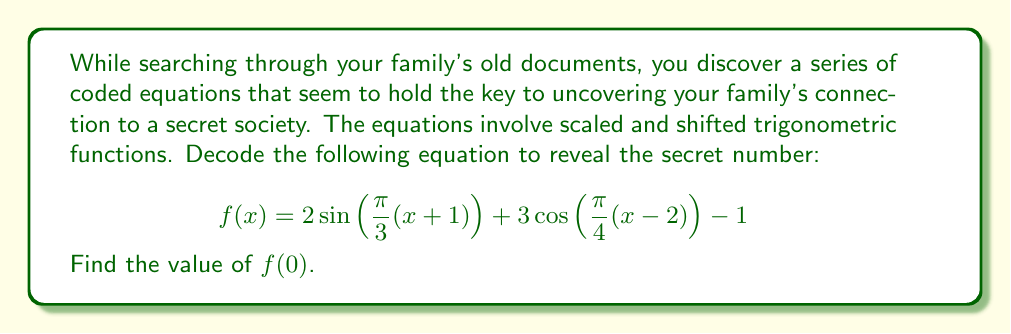Give your solution to this math problem. To solve this problem, we need to evaluate the function $f(x)$ at $x = 0$. Let's break it down step by step:

1) The function $f(x)$ consists of three parts:
   a) $2\sin\left(\frac{\pi}{3}(x+1)\right)$
   b) $3\cos\left(\frac{\pi}{4}(x-2)\right)$
   c) $-1$

2) Let's evaluate part (a) at $x = 0$:
   $2\sin\left(\frac{\pi}{3}(0+1)\right) = 2\sin\left(\frac{\pi}{3}\right) = 2 \cdot \frac{\sqrt{3}}{2} = \sqrt{3}$

3) Now, let's evaluate part (b) at $x = 0$:
   $3\cos\left(\frac{\pi}{4}(0-2)\right) = 3\cos\left(-\frac{\pi}{2}\right) = 3 \cdot 0 = 0$

4) Part (c) is simply $-1$

5) Now, we add all these parts together:
   $f(0) = \sqrt{3} + 0 - 1 = \sqrt{3} - 1$

Therefore, the value of $f(0)$ is $\sqrt{3} - 1$.
Answer: $\sqrt{3} - 1$ 